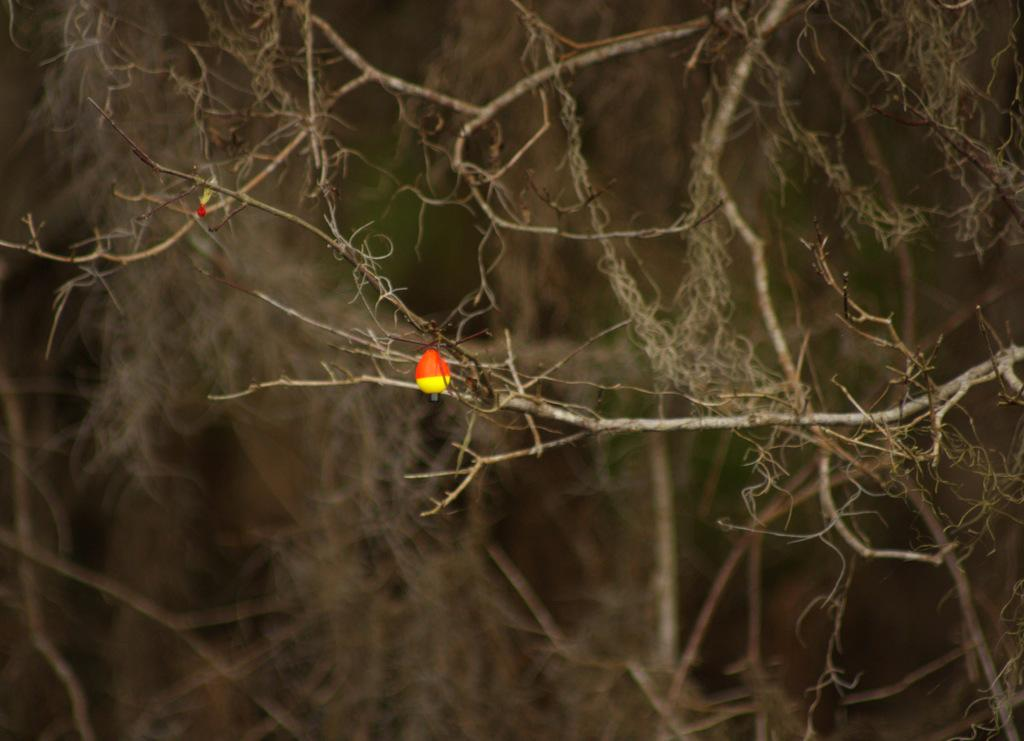What is hanging from the tree in the foreground of the image? There is an object hanging from a tree in the foreground of the image. Can you describe the background of the image? The background of the image is blurred. How many boats can be seen in the image? There are no boats present in the image. Where is the faucet located in the image? There is no faucet present in the image. 